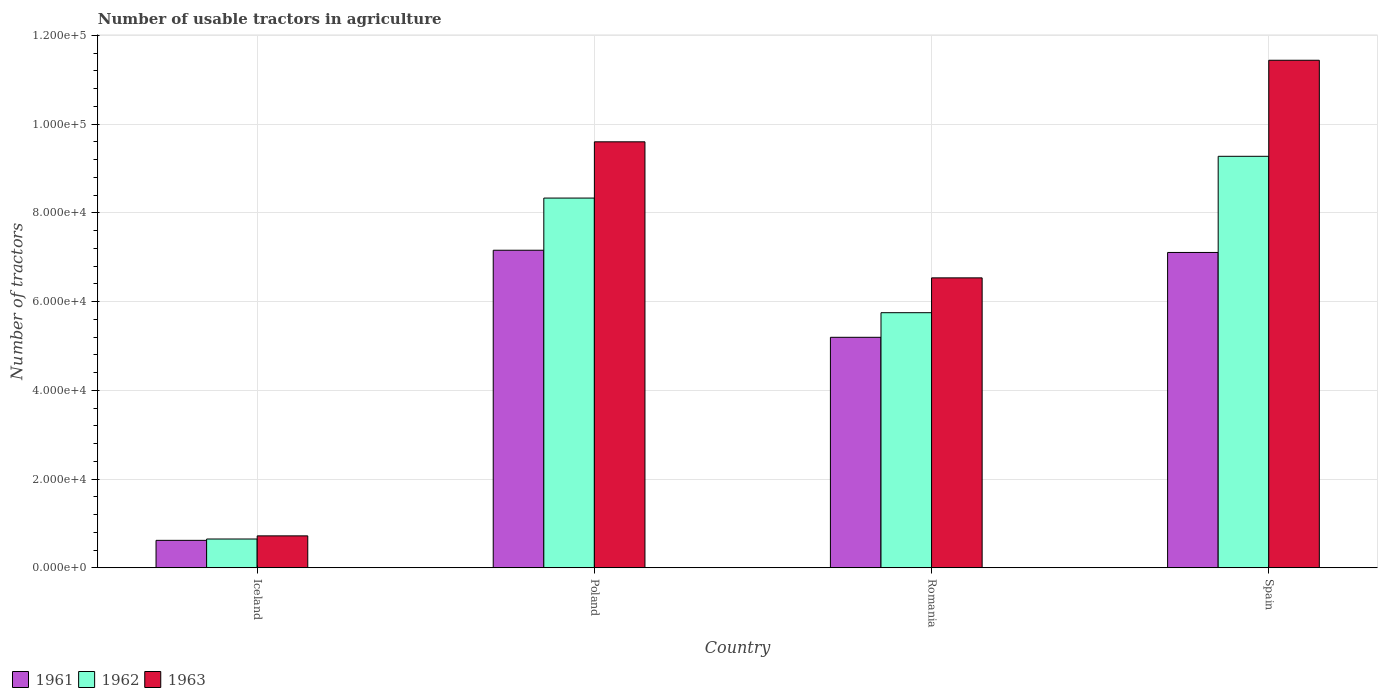How many different coloured bars are there?
Keep it short and to the point. 3. How many groups of bars are there?
Keep it short and to the point. 4. How many bars are there on the 2nd tick from the left?
Provide a succinct answer. 3. How many bars are there on the 4th tick from the right?
Ensure brevity in your answer.  3. What is the label of the 1st group of bars from the left?
Provide a short and direct response. Iceland. What is the number of usable tractors in agriculture in 1962 in Romania?
Your response must be concise. 5.75e+04. Across all countries, what is the maximum number of usable tractors in agriculture in 1961?
Provide a succinct answer. 7.16e+04. Across all countries, what is the minimum number of usable tractors in agriculture in 1962?
Keep it short and to the point. 6479. What is the total number of usable tractors in agriculture in 1962 in the graph?
Give a very brief answer. 2.40e+05. What is the difference between the number of usable tractors in agriculture in 1961 in Poland and that in Romania?
Ensure brevity in your answer.  1.96e+04. What is the difference between the number of usable tractors in agriculture in 1962 in Poland and the number of usable tractors in agriculture in 1961 in Spain?
Your answer should be very brief. 1.23e+04. What is the average number of usable tractors in agriculture in 1962 per country?
Provide a succinct answer. 6.00e+04. What is the difference between the number of usable tractors in agriculture of/in 1962 and number of usable tractors in agriculture of/in 1963 in Romania?
Your answer should be compact. -7851. What is the ratio of the number of usable tractors in agriculture in 1961 in Iceland to that in Romania?
Your response must be concise. 0.12. Is the difference between the number of usable tractors in agriculture in 1962 in Poland and Romania greater than the difference between the number of usable tractors in agriculture in 1963 in Poland and Romania?
Give a very brief answer. No. What is the difference between the highest and the second highest number of usable tractors in agriculture in 1963?
Provide a short and direct response. 1.84e+04. What is the difference between the highest and the lowest number of usable tractors in agriculture in 1963?
Provide a short and direct response. 1.07e+05. In how many countries, is the number of usable tractors in agriculture in 1963 greater than the average number of usable tractors in agriculture in 1963 taken over all countries?
Provide a short and direct response. 2. Is the sum of the number of usable tractors in agriculture in 1961 in Iceland and Romania greater than the maximum number of usable tractors in agriculture in 1963 across all countries?
Ensure brevity in your answer.  No. What does the 2nd bar from the left in Poland represents?
Your response must be concise. 1962. Is it the case that in every country, the sum of the number of usable tractors in agriculture in 1962 and number of usable tractors in agriculture in 1961 is greater than the number of usable tractors in agriculture in 1963?
Your response must be concise. Yes. How many bars are there?
Give a very brief answer. 12. How many countries are there in the graph?
Your answer should be very brief. 4. What is the difference between two consecutive major ticks on the Y-axis?
Ensure brevity in your answer.  2.00e+04. Are the values on the major ticks of Y-axis written in scientific E-notation?
Ensure brevity in your answer.  Yes. Does the graph contain grids?
Offer a very short reply. Yes. What is the title of the graph?
Provide a short and direct response. Number of usable tractors in agriculture. Does "2011" appear as one of the legend labels in the graph?
Provide a short and direct response. No. What is the label or title of the X-axis?
Provide a succinct answer. Country. What is the label or title of the Y-axis?
Make the answer very short. Number of tractors. What is the Number of tractors in 1961 in Iceland?
Offer a very short reply. 6177. What is the Number of tractors of 1962 in Iceland?
Provide a succinct answer. 6479. What is the Number of tractors in 1963 in Iceland?
Provide a short and direct response. 7187. What is the Number of tractors in 1961 in Poland?
Your answer should be very brief. 7.16e+04. What is the Number of tractors of 1962 in Poland?
Offer a very short reply. 8.33e+04. What is the Number of tractors of 1963 in Poland?
Make the answer very short. 9.60e+04. What is the Number of tractors in 1961 in Romania?
Keep it short and to the point. 5.20e+04. What is the Number of tractors in 1962 in Romania?
Your answer should be very brief. 5.75e+04. What is the Number of tractors in 1963 in Romania?
Your answer should be compact. 6.54e+04. What is the Number of tractors in 1961 in Spain?
Your response must be concise. 7.11e+04. What is the Number of tractors of 1962 in Spain?
Provide a short and direct response. 9.28e+04. What is the Number of tractors of 1963 in Spain?
Make the answer very short. 1.14e+05. Across all countries, what is the maximum Number of tractors of 1961?
Provide a succinct answer. 7.16e+04. Across all countries, what is the maximum Number of tractors in 1962?
Offer a very short reply. 9.28e+04. Across all countries, what is the maximum Number of tractors in 1963?
Your response must be concise. 1.14e+05. Across all countries, what is the minimum Number of tractors in 1961?
Provide a succinct answer. 6177. Across all countries, what is the minimum Number of tractors in 1962?
Your answer should be very brief. 6479. Across all countries, what is the minimum Number of tractors of 1963?
Your response must be concise. 7187. What is the total Number of tractors of 1961 in the graph?
Your response must be concise. 2.01e+05. What is the total Number of tractors of 1962 in the graph?
Offer a very short reply. 2.40e+05. What is the total Number of tractors in 1963 in the graph?
Provide a short and direct response. 2.83e+05. What is the difference between the Number of tractors of 1961 in Iceland and that in Poland?
Make the answer very short. -6.54e+04. What is the difference between the Number of tractors in 1962 in Iceland and that in Poland?
Your response must be concise. -7.69e+04. What is the difference between the Number of tractors of 1963 in Iceland and that in Poland?
Your response must be concise. -8.88e+04. What is the difference between the Number of tractors in 1961 in Iceland and that in Romania?
Your answer should be very brief. -4.58e+04. What is the difference between the Number of tractors of 1962 in Iceland and that in Romania?
Give a very brief answer. -5.10e+04. What is the difference between the Number of tractors in 1963 in Iceland and that in Romania?
Your answer should be very brief. -5.82e+04. What is the difference between the Number of tractors of 1961 in Iceland and that in Spain?
Offer a very short reply. -6.49e+04. What is the difference between the Number of tractors of 1962 in Iceland and that in Spain?
Ensure brevity in your answer.  -8.63e+04. What is the difference between the Number of tractors in 1963 in Iceland and that in Spain?
Offer a terse response. -1.07e+05. What is the difference between the Number of tractors of 1961 in Poland and that in Romania?
Your answer should be compact. 1.96e+04. What is the difference between the Number of tractors in 1962 in Poland and that in Romania?
Make the answer very short. 2.58e+04. What is the difference between the Number of tractors in 1963 in Poland and that in Romania?
Keep it short and to the point. 3.07e+04. What is the difference between the Number of tractors of 1962 in Poland and that in Spain?
Your response must be concise. -9414. What is the difference between the Number of tractors of 1963 in Poland and that in Spain?
Your answer should be very brief. -1.84e+04. What is the difference between the Number of tractors of 1961 in Romania and that in Spain?
Your response must be concise. -1.91e+04. What is the difference between the Number of tractors of 1962 in Romania and that in Spain?
Offer a terse response. -3.53e+04. What is the difference between the Number of tractors in 1963 in Romania and that in Spain?
Your answer should be compact. -4.91e+04. What is the difference between the Number of tractors of 1961 in Iceland and the Number of tractors of 1962 in Poland?
Keep it short and to the point. -7.72e+04. What is the difference between the Number of tractors of 1961 in Iceland and the Number of tractors of 1963 in Poland?
Give a very brief answer. -8.98e+04. What is the difference between the Number of tractors in 1962 in Iceland and the Number of tractors in 1963 in Poland?
Your response must be concise. -8.95e+04. What is the difference between the Number of tractors of 1961 in Iceland and the Number of tractors of 1962 in Romania?
Provide a succinct answer. -5.13e+04. What is the difference between the Number of tractors of 1961 in Iceland and the Number of tractors of 1963 in Romania?
Make the answer very short. -5.92e+04. What is the difference between the Number of tractors in 1962 in Iceland and the Number of tractors in 1963 in Romania?
Offer a terse response. -5.89e+04. What is the difference between the Number of tractors of 1961 in Iceland and the Number of tractors of 1962 in Spain?
Keep it short and to the point. -8.66e+04. What is the difference between the Number of tractors in 1961 in Iceland and the Number of tractors in 1963 in Spain?
Give a very brief answer. -1.08e+05. What is the difference between the Number of tractors in 1962 in Iceland and the Number of tractors in 1963 in Spain?
Your answer should be compact. -1.08e+05. What is the difference between the Number of tractors in 1961 in Poland and the Number of tractors in 1962 in Romania?
Your answer should be very brief. 1.41e+04. What is the difference between the Number of tractors in 1961 in Poland and the Number of tractors in 1963 in Romania?
Your answer should be very brief. 6226. What is the difference between the Number of tractors in 1962 in Poland and the Number of tractors in 1963 in Romania?
Your response must be concise. 1.80e+04. What is the difference between the Number of tractors of 1961 in Poland and the Number of tractors of 1962 in Spain?
Ensure brevity in your answer.  -2.12e+04. What is the difference between the Number of tractors of 1961 in Poland and the Number of tractors of 1963 in Spain?
Your answer should be compact. -4.28e+04. What is the difference between the Number of tractors of 1962 in Poland and the Number of tractors of 1963 in Spain?
Provide a succinct answer. -3.11e+04. What is the difference between the Number of tractors of 1961 in Romania and the Number of tractors of 1962 in Spain?
Give a very brief answer. -4.08e+04. What is the difference between the Number of tractors of 1961 in Romania and the Number of tractors of 1963 in Spain?
Offer a terse response. -6.25e+04. What is the difference between the Number of tractors of 1962 in Romania and the Number of tractors of 1963 in Spain?
Provide a succinct answer. -5.69e+04. What is the average Number of tractors in 1961 per country?
Give a very brief answer. 5.02e+04. What is the average Number of tractors in 1962 per country?
Your answer should be very brief. 6.00e+04. What is the average Number of tractors in 1963 per country?
Provide a succinct answer. 7.07e+04. What is the difference between the Number of tractors in 1961 and Number of tractors in 1962 in Iceland?
Offer a terse response. -302. What is the difference between the Number of tractors in 1961 and Number of tractors in 1963 in Iceland?
Your answer should be very brief. -1010. What is the difference between the Number of tractors of 1962 and Number of tractors of 1963 in Iceland?
Your answer should be very brief. -708. What is the difference between the Number of tractors of 1961 and Number of tractors of 1962 in Poland?
Your response must be concise. -1.18e+04. What is the difference between the Number of tractors in 1961 and Number of tractors in 1963 in Poland?
Keep it short and to the point. -2.44e+04. What is the difference between the Number of tractors of 1962 and Number of tractors of 1963 in Poland?
Keep it short and to the point. -1.27e+04. What is the difference between the Number of tractors in 1961 and Number of tractors in 1962 in Romania?
Your response must be concise. -5548. What is the difference between the Number of tractors of 1961 and Number of tractors of 1963 in Romania?
Your answer should be very brief. -1.34e+04. What is the difference between the Number of tractors in 1962 and Number of tractors in 1963 in Romania?
Provide a short and direct response. -7851. What is the difference between the Number of tractors of 1961 and Number of tractors of 1962 in Spain?
Provide a short and direct response. -2.17e+04. What is the difference between the Number of tractors of 1961 and Number of tractors of 1963 in Spain?
Give a very brief answer. -4.33e+04. What is the difference between the Number of tractors of 1962 and Number of tractors of 1963 in Spain?
Your response must be concise. -2.17e+04. What is the ratio of the Number of tractors of 1961 in Iceland to that in Poland?
Your answer should be very brief. 0.09. What is the ratio of the Number of tractors in 1962 in Iceland to that in Poland?
Provide a short and direct response. 0.08. What is the ratio of the Number of tractors in 1963 in Iceland to that in Poland?
Give a very brief answer. 0.07. What is the ratio of the Number of tractors in 1961 in Iceland to that in Romania?
Give a very brief answer. 0.12. What is the ratio of the Number of tractors in 1962 in Iceland to that in Romania?
Provide a succinct answer. 0.11. What is the ratio of the Number of tractors of 1963 in Iceland to that in Romania?
Ensure brevity in your answer.  0.11. What is the ratio of the Number of tractors of 1961 in Iceland to that in Spain?
Offer a terse response. 0.09. What is the ratio of the Number of tractors in 1962 in Iceland to that in Spain?
Your response must be concise. 0.07. What is the ratio of the Number of tractors in 1963 in Iceland to that in Spain?
Ensure brevity in your answer.  0.06. What is the ratio of the Number of tractors in 1961 in Poland to that in Romania?
Give a very brief answer. 1.38. What is the ratio of the Number of tractors in 1962 in Poland to that in Romania?
Provide a succinct answer. 1.45. What is the ratio of the Number of tractors in 1963 in Poland to that in Romania?
Provide a short and direct response. 1.47. What is the ratio of the Number of tractors in 1961 in Poland to that in Spain?
Offer a terse response. 1.01. What is the ratio of the Number of tractors of 1962 in Poland to that in Spain?
Offer a very short reply. 0.9. What is the ratio of the Number of tractors of 1963 in Poland to that in Spain?
Your response must be concise. 0.84. What is the ratio of the Number of tractors in 1961 in Romania to that in Spain?
Give a very brief answer. 0.73. What is the ratio of the Number of tractors in 1962 in Romania to that in Spain?
Ensure brevity in your answer.  0.62. What is the ratio of the Number of tractors of 1963 in Romania to that in Spain?
Your response must be concise. 0.57. What is the difference between the highest and the second highest Number of tractors in 1962?
Provide a short and direct response. 9414. What is the difference between the highest and the second highest Number of tractors in 1963?
Your answer should be very brief. 1.84e+04. What is the difference between the highest and the lowest Number of tractors in 1961?
Make the answer very short. 6.54e+04. What is the difference between the highest and the lowest Number of tractors of 1962?
Provide a short and direct response. 8.63e+04. What is the difference between the highest and the lowest Number of tractors in 1963?
Your answer should be compact. 1.07e+05. 